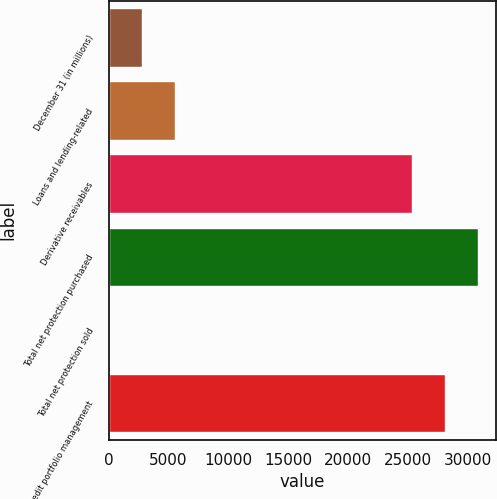Convert chart. <chart><loc_0><loc_0><loc_500><loc_500><bar_chart><fcel>December 31 (in millions)<fcel>Loans and lending-related<fcel>Derivative receivables<fcel>Total net protection purchased<fcel>Total net protection sold<fcel>Credit portfolio management<nl><fcel>2810.7<fcel>5555.4<fcel>25347<fcel>30836.4<fcel>66<fcel>28091.7<nl></chart> 